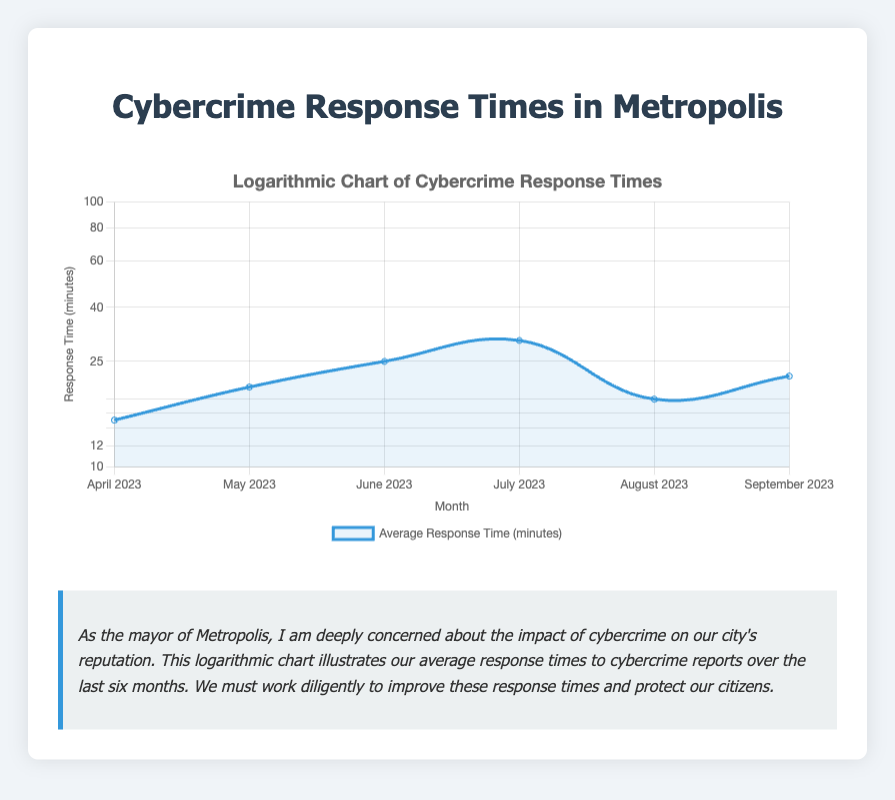What was the average response time in April 2023? The table shows that the average response time for April 2023 is 15 minutes.
Answer: 15 minutes Which month had the longest average response time? By comparing the average response times from the table, July 2023 has the longest response time at 30 minutes.
Answer: July 2023 What is the average response time over the last six months? To find the average, sum all the average response times (15 + 20 + 25 + 30 + 18 + 22 = 140) and divide by the number of months (6). Thus, the average is 140/6 ≈ 23.33 minutes.
Answer: Approximately 23.33 minutes Did the average response times increase from April to July 2023? From the table, the average response times were 15 minutes in April and 30 minutes in July, indicating an increase.
Answer: Yes In which month did we observe a drop in the average response time compared to the previous month? Observing the table shows a drop from July (30 minutes) to August (18 minutes), so this is the month with a decrease.
Answer: August 2023 What was the change in average response time from June to September 2023? June's average response time is 25 minutes, and September's is 22 minutes. Thus, the change is 22 - 25 = -3 minutes, indicating a decrease.
Answer: -3 minutes Was the average response time in May 2023 higher than that in August 2023? The average response time in May is 20 minutes, and in August it is 18 minutes, thus May's time was higher.
Answer: Yes How many months had an average response time above 20 minutes? Reviewing the table, the months with average response times above 20 minutes are May, June, and July, which is a total of three months.
Answer: 3 months 